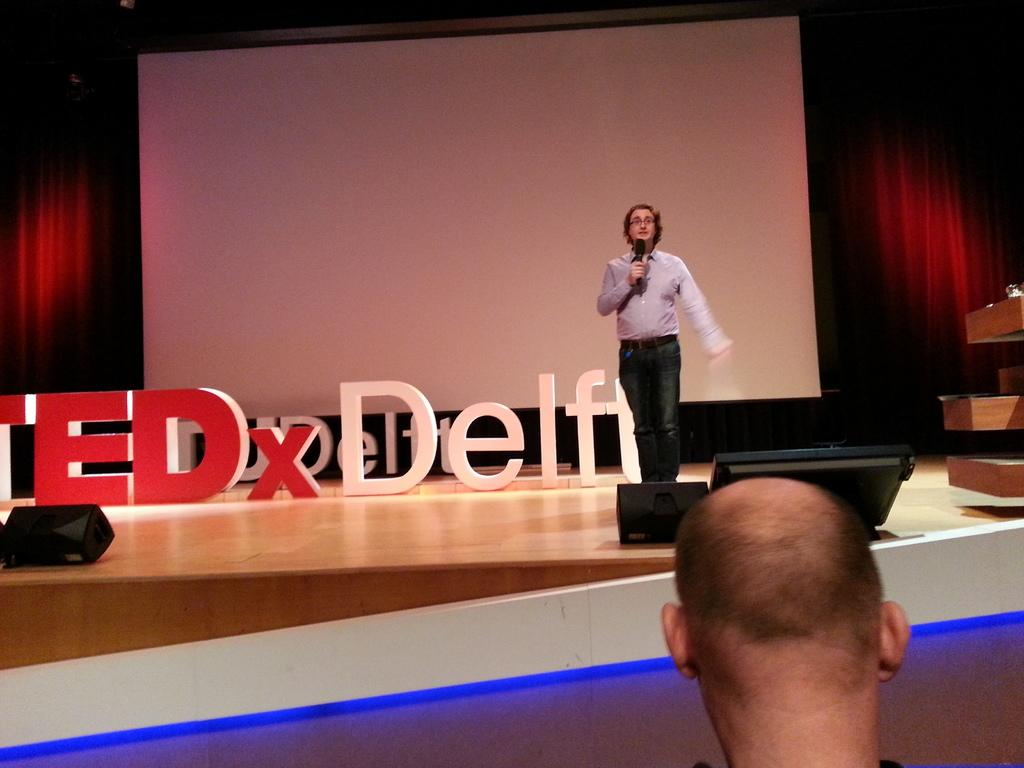What is the man in the image holding? The man is holding a mic in the image. Where is the man standing? The man is standing on a stage. What can be seen in front of the man on stage? There are lights in front of the man on stage. What is visible behind the man on stage? There is a screen behind the man on stage. Can you describe the person in the front of the image? There is a bald-headed man visible in the front of the image. Reasoning: Let's think step by step by following the provided facts step by step to create the conversation. We start by identifying the main subject, which is the man holding a mic. Then, we describe the location of the man, which is on a stage. Next, we mention the objects in front of and behind the man on stage. Finally, we describe the person in the front of the image. Absurd Question/Answer: How many balloons are floating above the man's head in the image? There are no balloons visible in the image. What type of secretary is sitting next to the bald-headed man in the image? There is no secretary present in the image. 